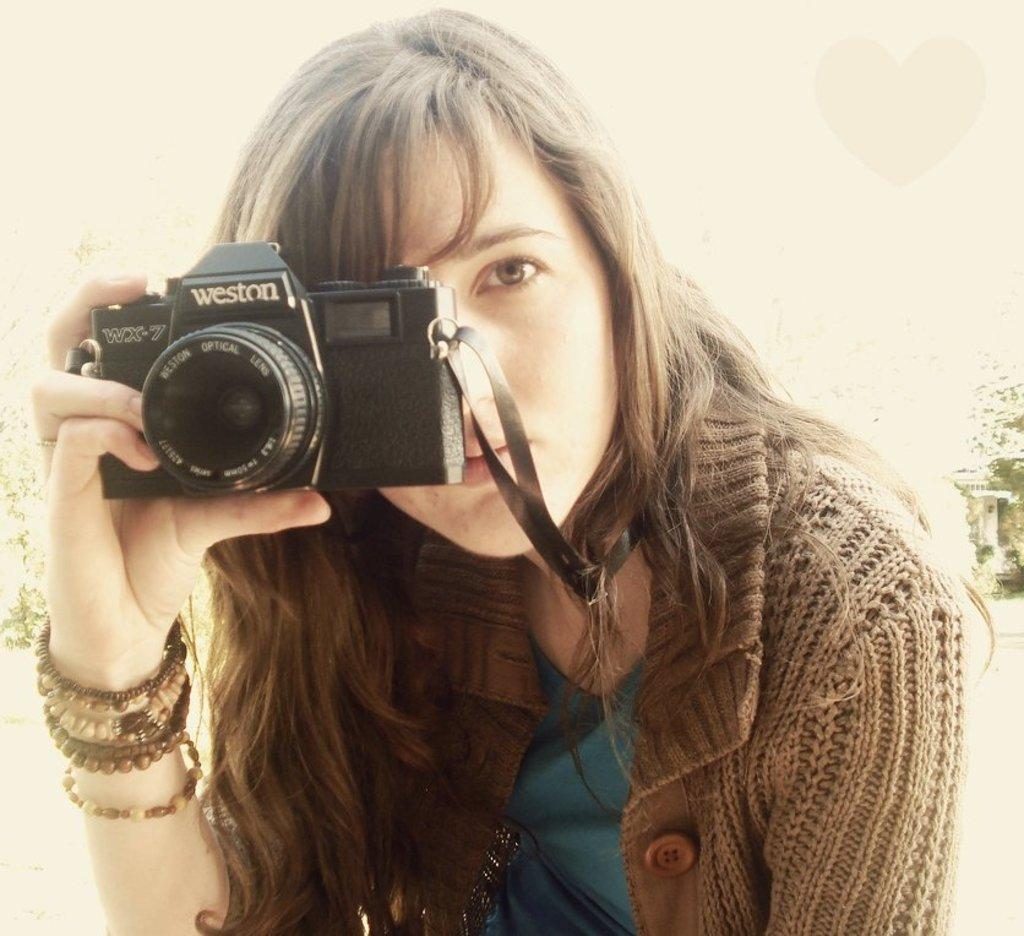In one or two sentences, can you explain what this image depicts? As we can see in the image, there is a woman holding camera. 